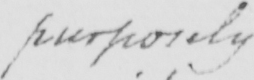Transcribe the text shown in this historical manuscript line. purposely 